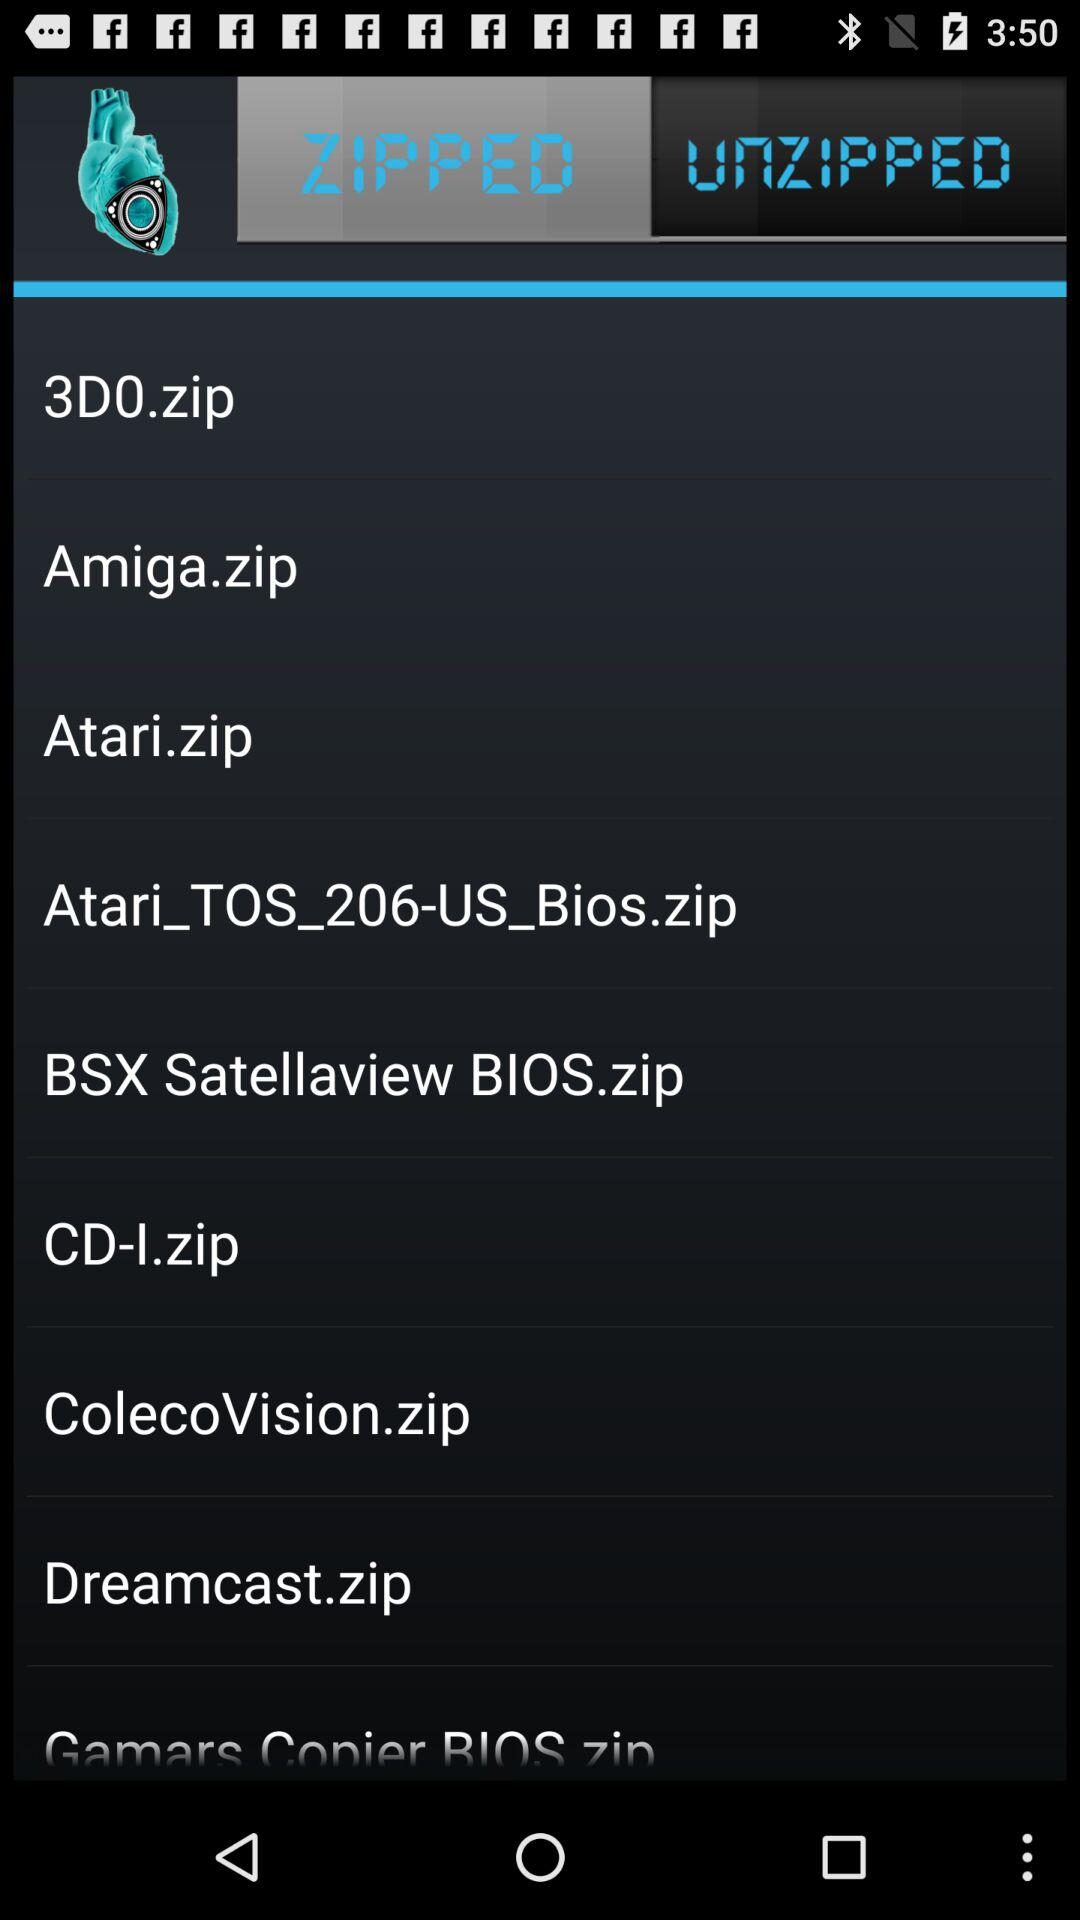Which are the different zip files? The different zip files are "3D0.zip", "Amiga.zip", "Atari.zip", "Atari_TOS_206-US_Bios.zip", "BSX Satellaview BIOS.zip", "CD-I.zip", "ColecoVision.zip" and "Dreamcast.zip". 